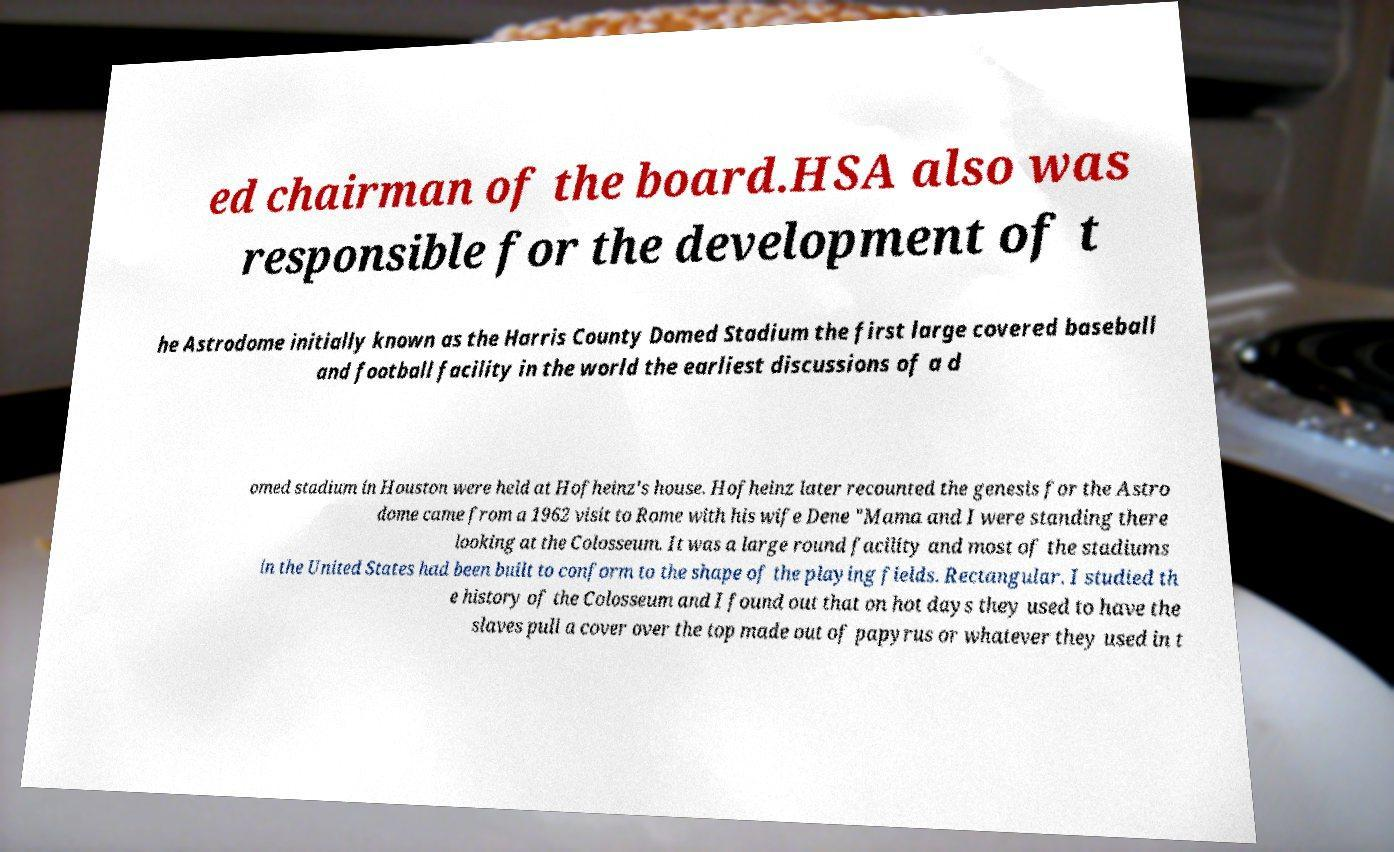There's text embedded in this image that I need extracted. Can you transcribe it verbatim? ed chairman of the board.HSA also was responsible for the development of t he Astrodome initially known as the Harris County Domed Stadium the first large covered baseball and football facility in the world the earliest discussions of a d omed stadium in Houston were held at Hofheinz's house. Hofheinz later recounted the genesis for the Astro dome came from a 1962 visit to Rome with his wife Dene "Mama and I were standing there looking at the Colosseum. It was a large round facility and most of the stadiums in the United States had been built to conform to the shape of the playing fields. Rectangular. I studied th e history of the Colosseum and I found out that on hot days they used to have the slaves pull a cover over the top made out of papyrus or whatever they used in t 